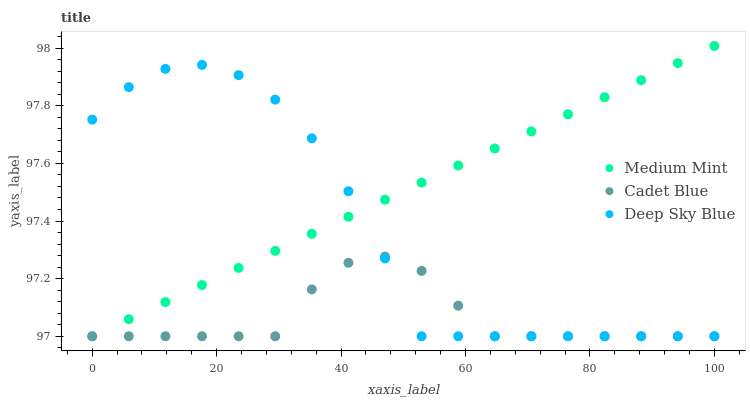Does Cadet Blue have the minimum area under the curve?
Answer yes or no. Yes. Does Medium Mint have the maximum area under the curve?
Answer yes or no. Yes. Does Deep Sky Blue have the minimum area under the curve?
Answer yes or no. No. Does Deep Sky Blue have the maximum area under the curve?
Answer yes or no. No. Is Medium Mint the smoothest?
Answer yes or no. Yes. Is Deep Sky Blue the roughest?
Answer yes or no. Yes. Is Cadet Blue the smoothest?
Answer yes or no. No. Is Cadet Blue the roughest?
Answer yes or no. No. Does Medium Mint have the lowest value?
Answer yes or no. Yes. Does Medium Mint have the highest value?
Answer yes or no. Yes. Does Deep Sky Blue have the highest value?
Answer yes or no. No. Does Medium Mint intersect Deep Sky Blue?
Answer yes or no. Yes. Is Medium Mint less than Deep Sky Blue?
Answer yes or no. No. Is Medium Mint greater than Deep Sky Blue?
Answer yes or no. No. 